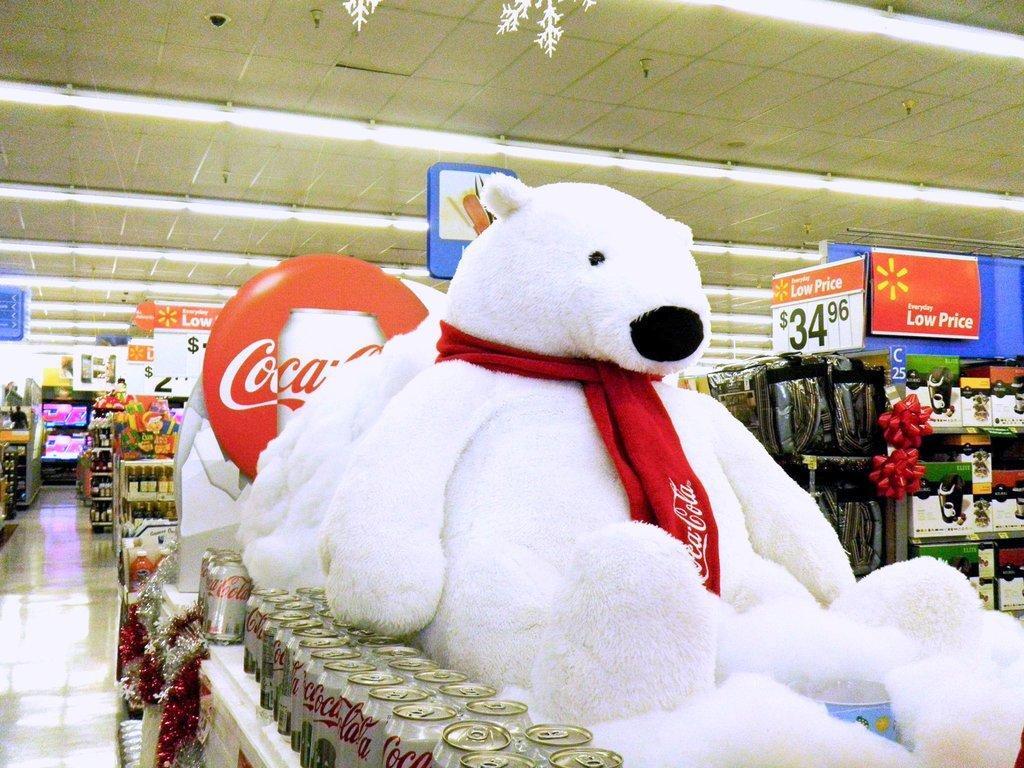Could you give a brief overview of what you see in this image? In this picture I can see cans on the racks. I can see a number of objects on the racks in the background. I can see light arrangements on the roof. I can see the teddy bear on the right side. 